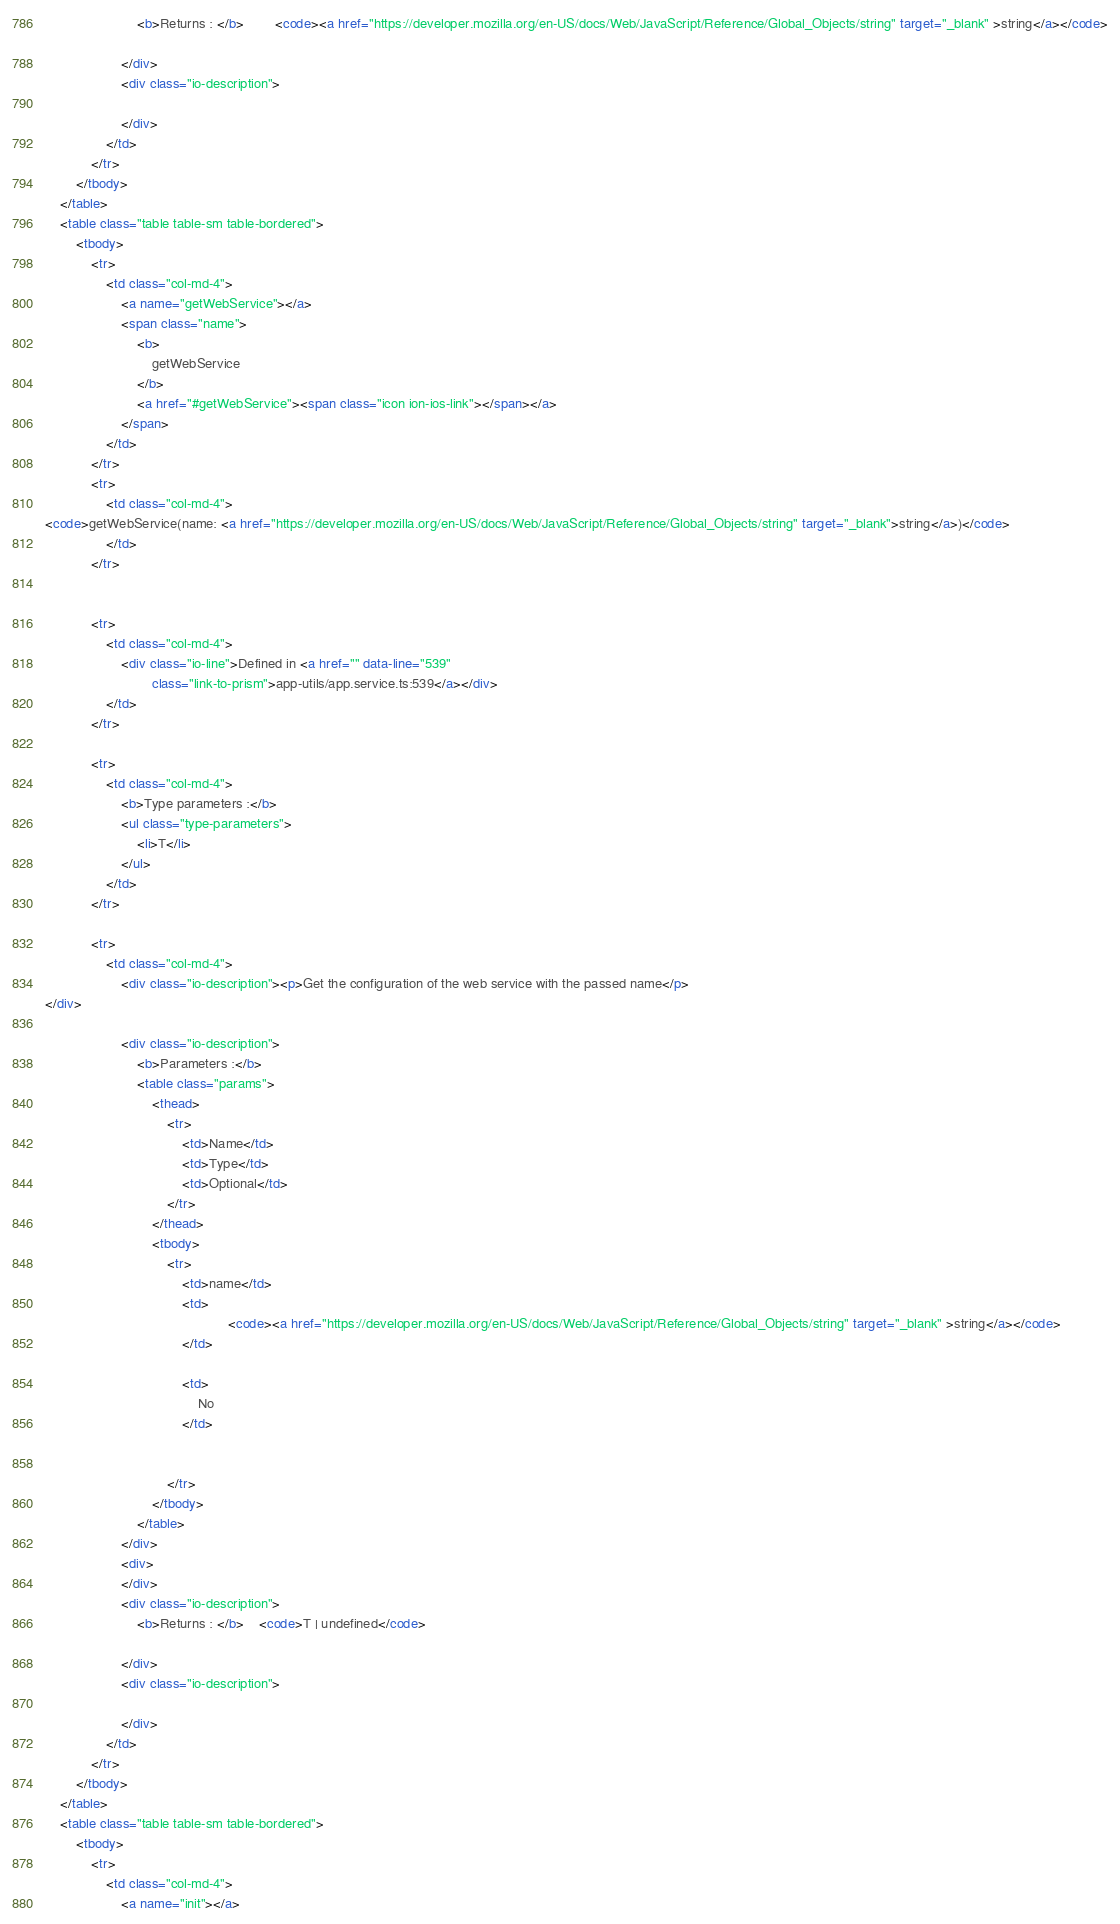Convert code to text. <code><loc_0><loc_0><loc_500><loc_500><_HTML_>                        <b>Returns : </b>        <code><a href="https://developer.mozilla.org/en-US/docs/Web/JavaScript/Reference/Global_Objects/string" target="_blank" >string</a></code>

                    </div>
                    <div class="io-description">
                        
                    </div>
                </td>
            </tr>
        </tbody>
    </table>
    <table class="table table-sm table-bordered">
        <tbody>
            <tr>
                <td class="col-md-4">
                    <a name="getWebService"></a>
                    <span class="name">
                        <b>
                            getWebService
                        </b>
                        <a href="#getWebService"><span class="icon ion-ios-link"></span></a>
                    </span>
                </td>
            </tr>
            <tr>
                <td class="col-md-4">
<code>getWebService(name: <a href="https://developer.mozilla.org/en-US/docs/Web/JavaScript/Reference/Global_Objects/string" target="_blank">string</a>)</code>
                </td>
            </tr>


            <tr>
                <td class="col-md-4">
                    <div class="io-line">Defined in <a href="" data-line="539"
                            class="link-to-prism">app-utils/app.service.ts:539</a></div>
                </td>
            </tr>

            <tr>
                <td class="col-md-4">
                    <b>Type parameters :</b>
                    <ul class="type-parameters">
                        <li>T</li>
                    </ul>
                </td>
            </tr>

            <tr>
                <td class="col-md-4">
                    <div class="io-description"><p>Get the configuration of the web service with the passed name</p>
</div>

                    <div class="io-description">
                        <b>Parameters :</b>
                        <table class="params">
                            <thead>
                                <tr>
                                    <td>Name</td>
                                    <td>Type</td>
                                    <td>Optional</td>
                                </tr>
                            </thead>
                            <tbody>
                                <tr>
                                    <td>name</td>
                                    <td>
                                                <code><a href="https://developer.mozilla.org/en-US/docs/Web/JavaScript/Reference/Global_Objects/string" target="_blank" >string</a></code>
                                    </td>

                                    <td>
                                        No
                                    </td>


                                </tr>
                            </tbody>
                        </table>
                    </div>
                    <div>
                    </div>
                    <div class="io-description">
                        <b>Returns : </b>    <code>T | undefined</code>

                    </div>
                    <div class="io-description">
                        
                    </div>
                </td>
            </tr>
        </tbody>
    </table>
    <table class="table table-sm table-bordered">
        <tbody>
            <tr>
                <td class="col-md-4">
                    <a name="init"></a></code> 